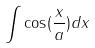Convert formula to latex. <formula><loc_0><loc_0><loc_500><loc_500>\int \cos ( \frac { x } { a } ) d x</formula> 